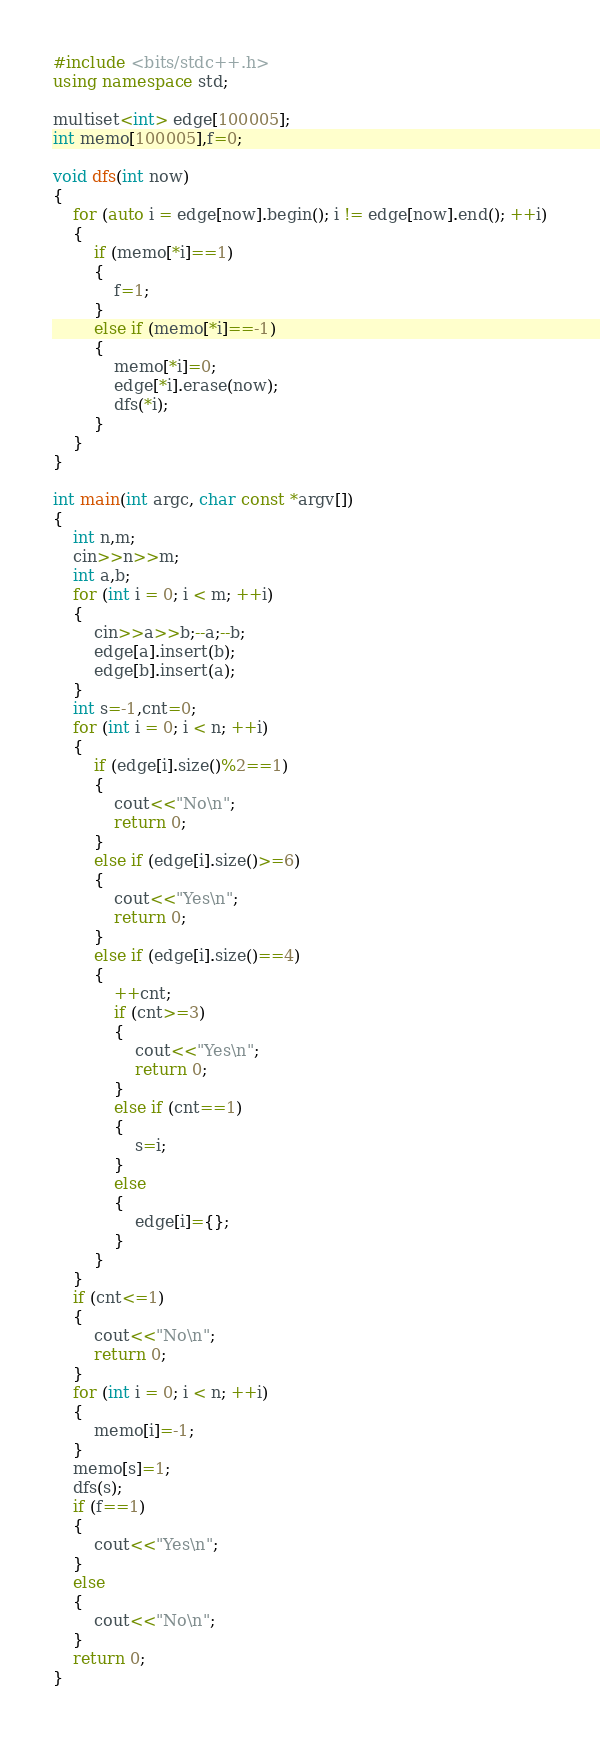Convert code to text. <code><loc_0><loc_0><loc_500><loc_500><_C++_>#include <bits/stdc++.h>
using namespace std;

multiset<int> edge[100005];
int memo[100005],f=0;

void dfs(int now)
{
	for (auto i = edge[now].begin(); i != edge[now].end(); ++i)
	{
		if (memo[*i]==1)
		{
			f=1;
		}
		else if (memo[*i]==-1)
		{
			memo[*i]=0;
			edge[*i].erase(now);
			dfs(*i);
		}
	}
}

int main(int argc, char const *argv[])
{
	int n,m;
	cin>>n>>m;
	int a,b;
	for (int i = 0; i < m; ++i)
	{
		cin>>a>>b;--a;--b;
		edge[a].insert(b);
		edge[b].insert(a);
	}
	int s=-1,cnt=0;
	for (int i = 0; i < n; ++i)
	{
		if (edge[i].size()%2==1)
		{
			cout<<"No\n";
			return 0;
		}
		else if (edge[i].size()>=6)
		{
			cout<<"Yes\n";
			return 0;
		}
		else if (edge[i].size()==4)
		{
			++cnt;
			if (cnt>=3)
			{
				cout<<"Yes\n";
				return 0;
			}
			else if (cnt==1)
			{
				s=i;
			}
			else
			{
				edge[i]={};
			}
		}
	}
	if (cnt<=1)
	{
		cout<<"No\n";
		return 0;
	}
	for (int i = 0; i < n; ++i)
	{
		memo[i]=-1;
	}
	memo[s]=1;
	dfs(s);
	if (f==1)
	{
		cout<<"Yes\n";
	}
	else
	{
		cout<<"No\n";
	}
	return 0;
}
</code> 